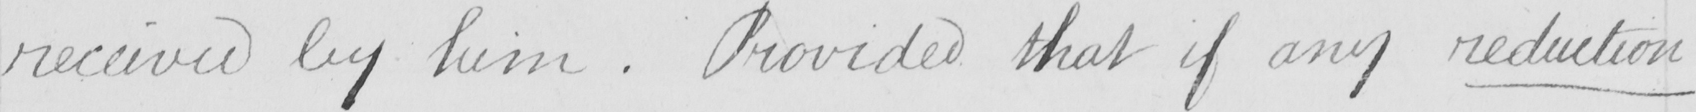What does this handwritten line say? received by him  . Provided that if any reduction 